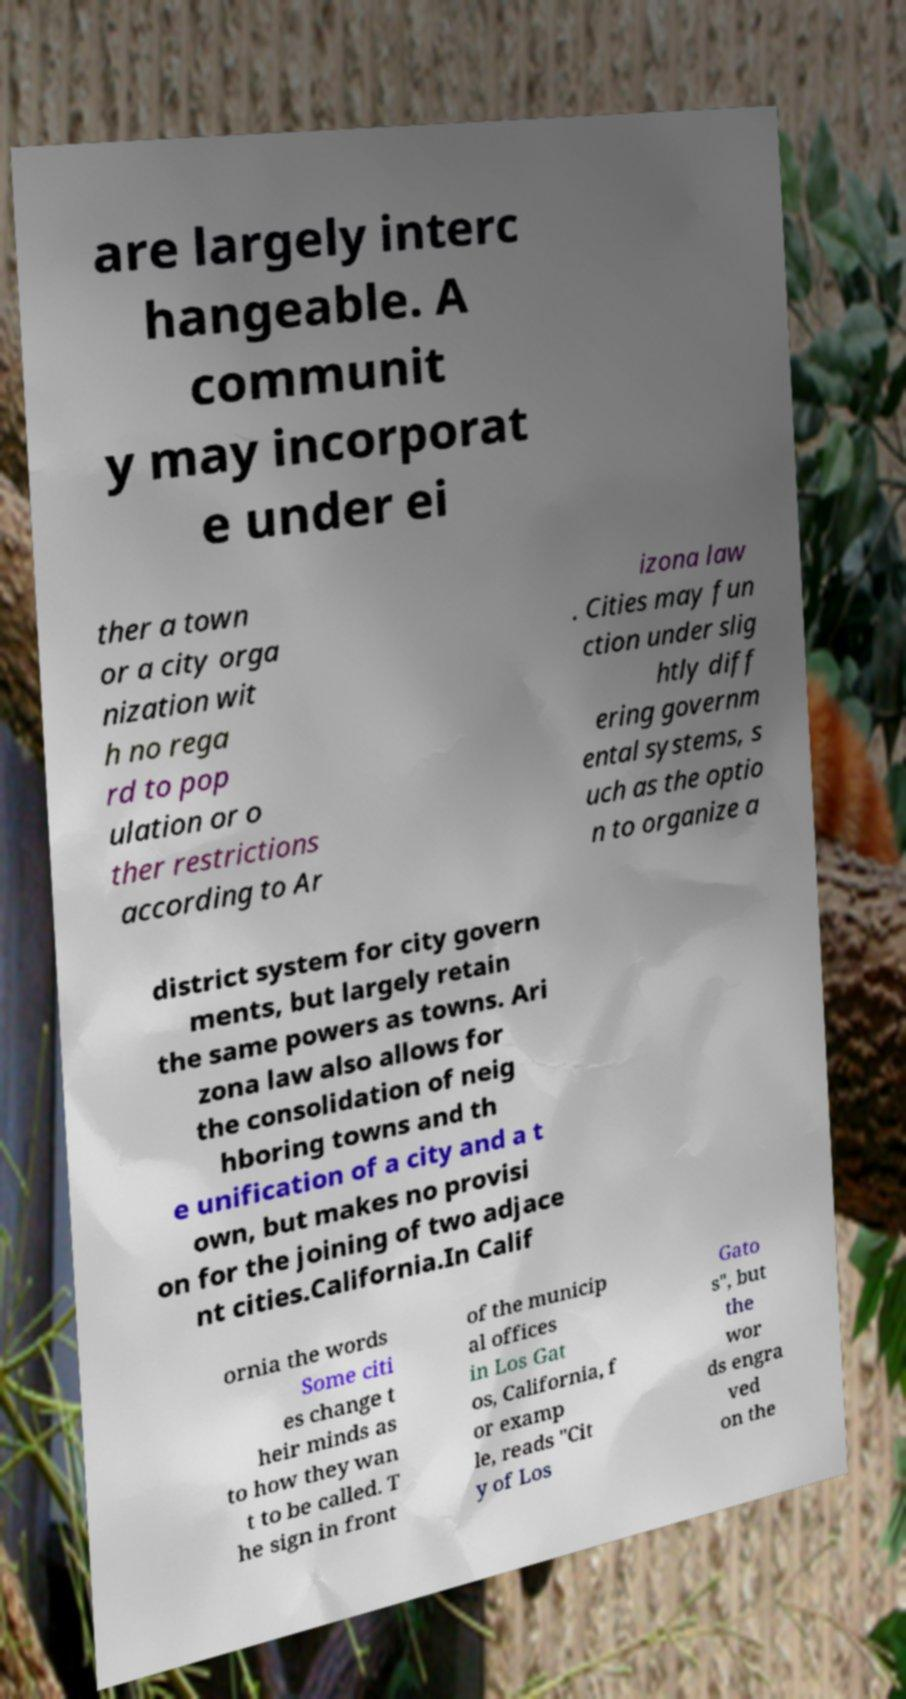There's text embedded in this image that I need extracted. Can you transcribe it verbatim? are largely interc hangeable. A communit y may incorporat e under ei ther a town or a city orga nization wit h no rega rd to pop ulation or o ther restrictions according to Ar izona law . Cities may fun ction under slig htly diff ering governm ental systems, s uch as the optio n to organize a district system for city govern ments, but largely retain the same powers as towns. Ari zona law also allows for the consolidation of neig hboring towns and th e unification of a city and a t own, but makes no provisi on for the joining of two adjace nt cities.California.In Calif ornia the words Some citi es change t heir minds as to how they wan t to be called. T he sign in front of the municip al offices in Los Gat os, California, f or examp le, reads "Cit y of Los Gato s", but the wor ds engra ved on the 